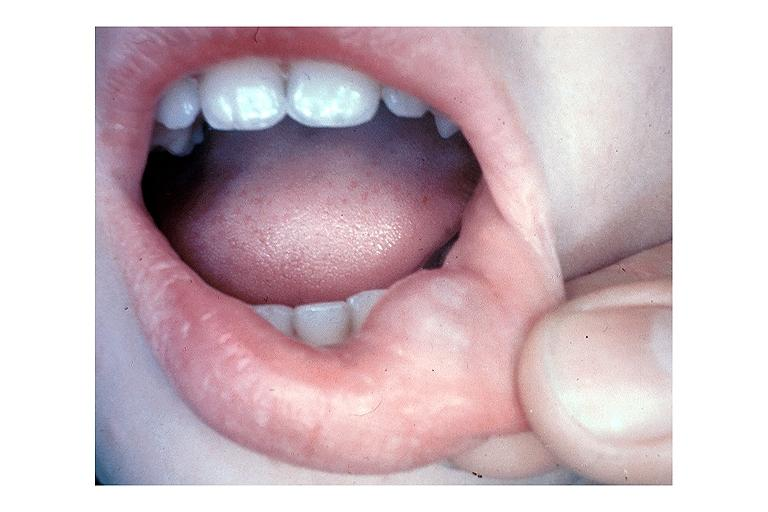what is present?
Answer the question using a single word or phrase. Oral 